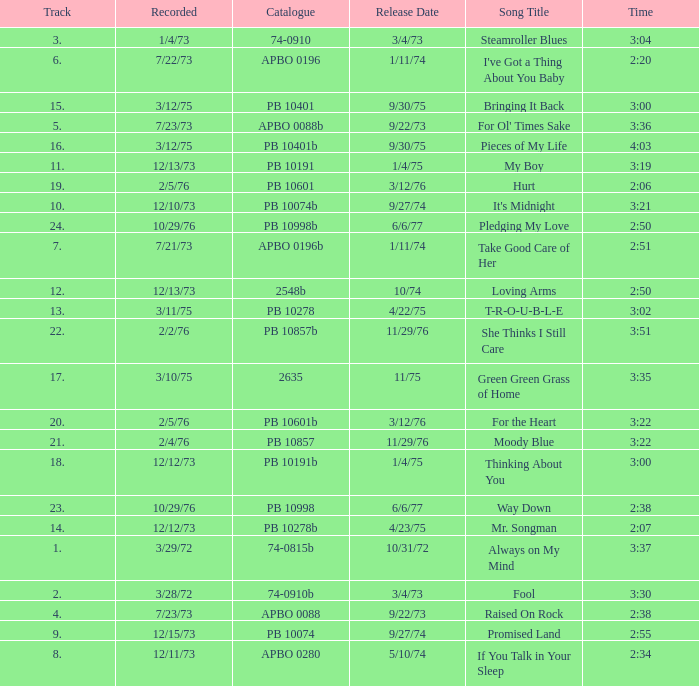Tell me the track that has the catalogue of apbo 0280 8.0. 